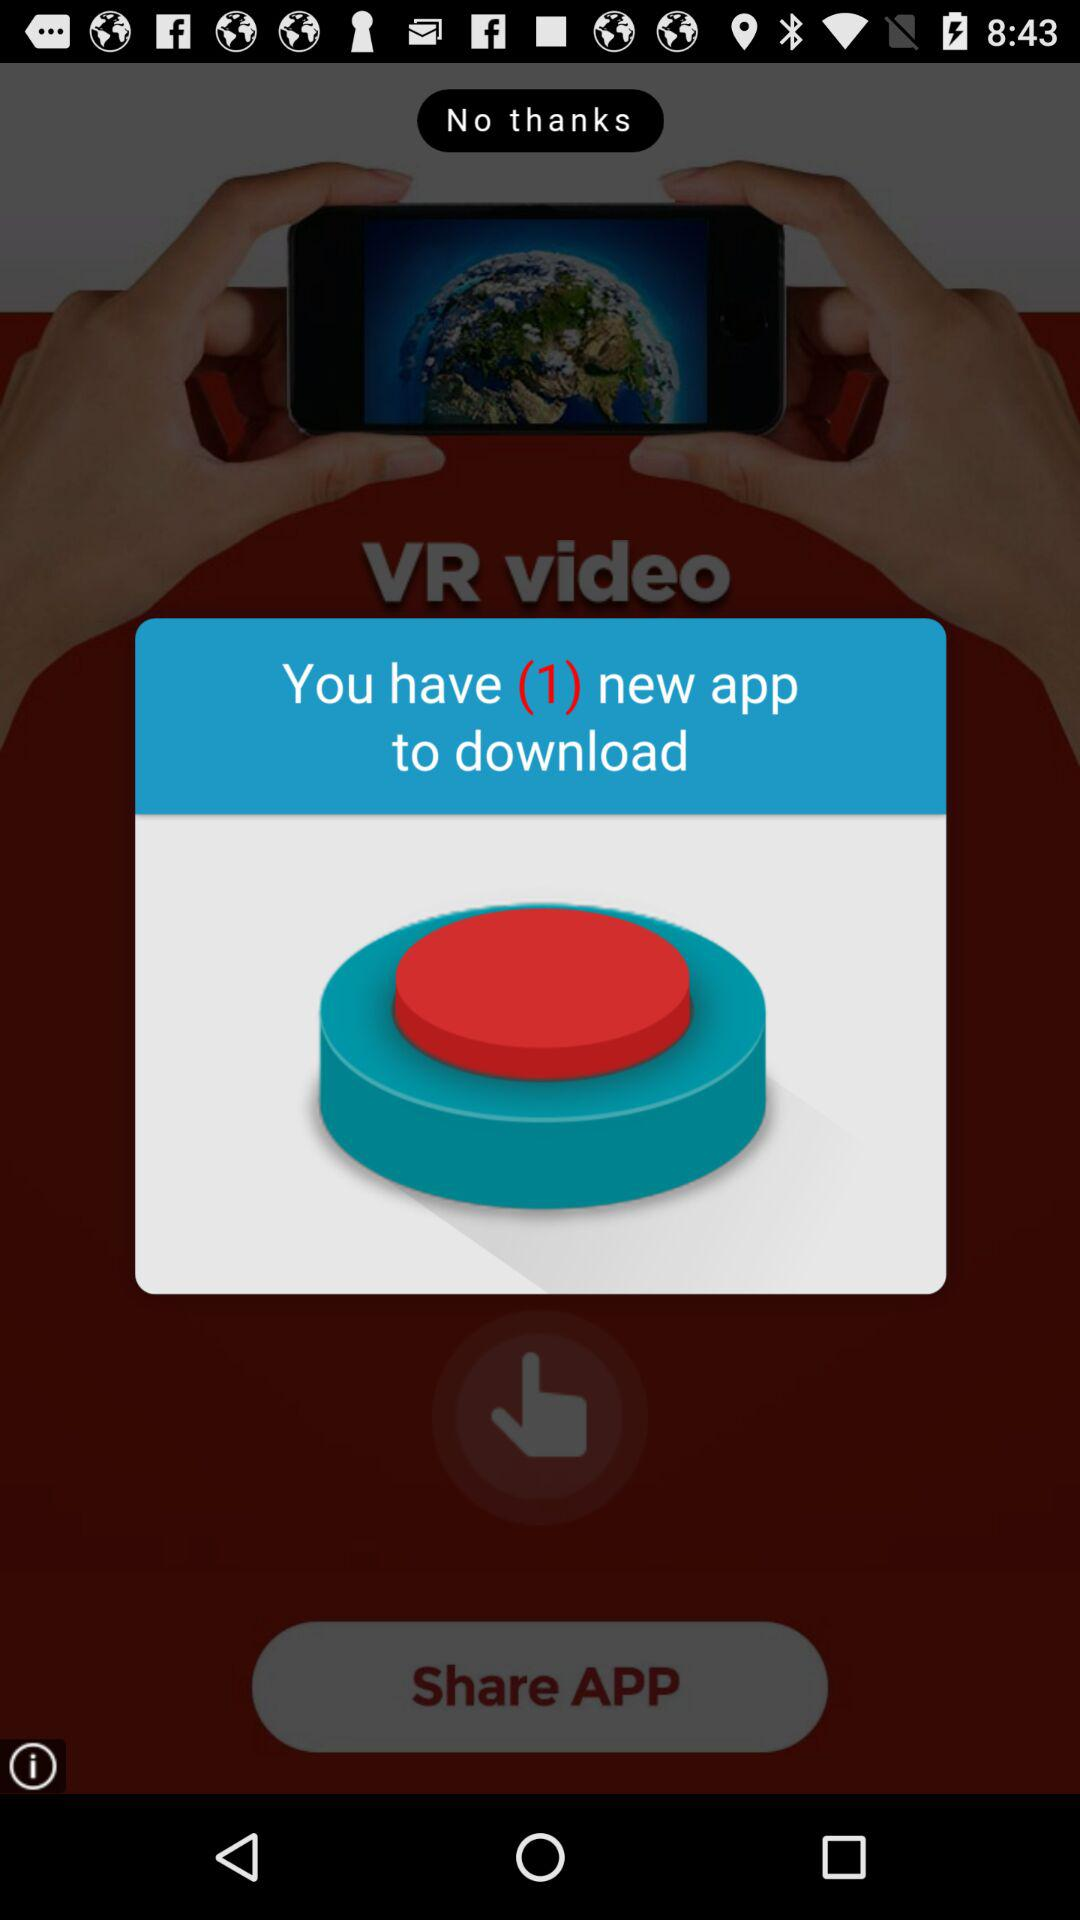Which application is available to download?
When the provided information is insufficient, respond with <no answer>. <no answer> 